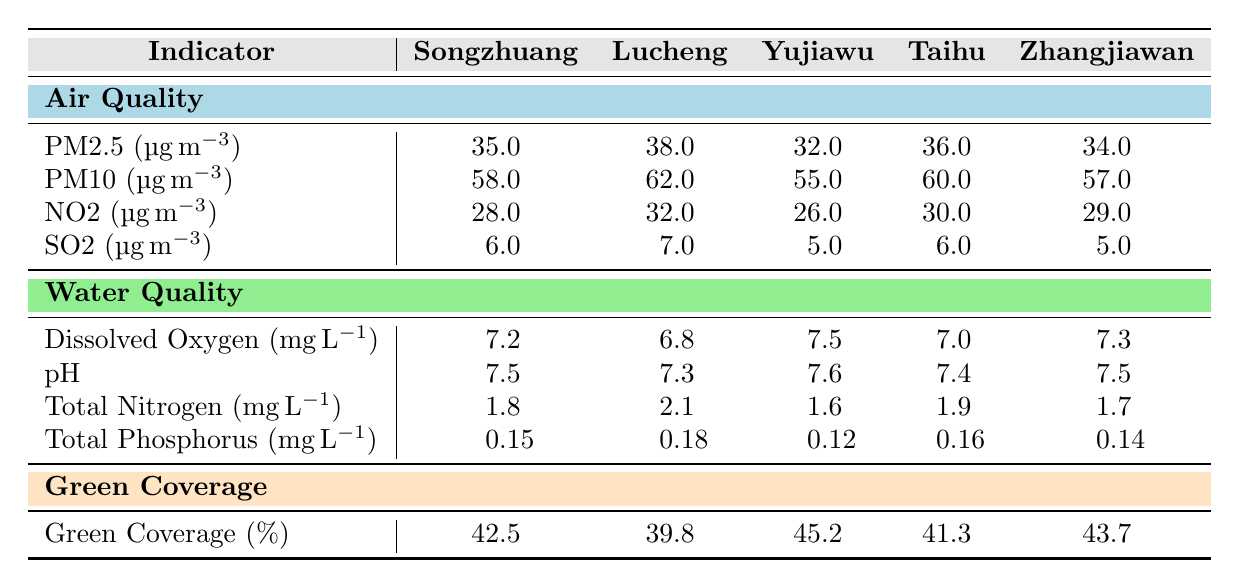What is the PM2.5 level in Yujiawu? Referring to the air quality section of the table, the PM2.5 level listed for Yujiawu is 32 μg/m³.
Answer: 32 μg/m³ Which area has the highest green coverage percentage? Looking at the green coverage section, the area with the highest percentage is Yujiawu, with 45.2%.
Answer: Yujiawu What is the difference in total nitrogen levels between Lucheng and Zhangjiawan? The total nitrogen level in Lucheng is 2.1 mg/L and in Zhangjiawan is 1.7 mg/L. The difference is 2.1 - 1.7 = 0.4 mg/L.
Answer: 0.4 mg/L Is the dissolved oxygen level in Taihu greater than that in Songzhuang? The dissolved oxygen in Taihu is 7.0 mg/L and in Songzhuang is 7.2 mg/L; therefore, 7.0 is not greater than 7.2.
Answer: No What is the average PM10 level across all areas? The PM10 levels are: 58, 62, 55, 60, and 57. Adding them gives 58 + 62 + 55 + 60 + 57 = 292. Dividing by 5 yields an average of 292/5 = 58.4.
Answer: 58.4 μg/m³ Which area has the lowest level of SO2? From the air quality data, SO2 levels are: 6, 7, 5, 6, 5 for each area. The lowest value is found in Yujiawu and Zhangjiawan at 5 μg/m³.
Answer: Yujiawu and Zhangjiawan What is the total phosphorus level in Lucheng and how does it compare to Taihu? Lucheng has a total phosphorus level of 0.18 mg/L and Taihu has 0.16 mg/L. Comparing the two: 0.18 is greater than 0.16.
Answer: Lucheng is greater than Taihu How many areas have a pH level greater than 7.5? The pH levels listed are: 7.5, 7.3, 7.6, 7.4, and 7.5. Only Yujiawu has a pH greater than 7.5 at 7.6.
Answer: 1 area What is the highest level of NO2 in all areas? In the air quality section, the NO2 levels are: 28, 32, 26, 30, and 29. The highest level is found in Lucheng, which is 32 μg/m³.
Answer: 32 μg/m³ If an area has a green coverage percentage below 40%, which area is it? The table shows that Lucheng has a green coverage of 39.8%, which is below 40%. No other areas fall below this threshold.
Answer: Lucheng 